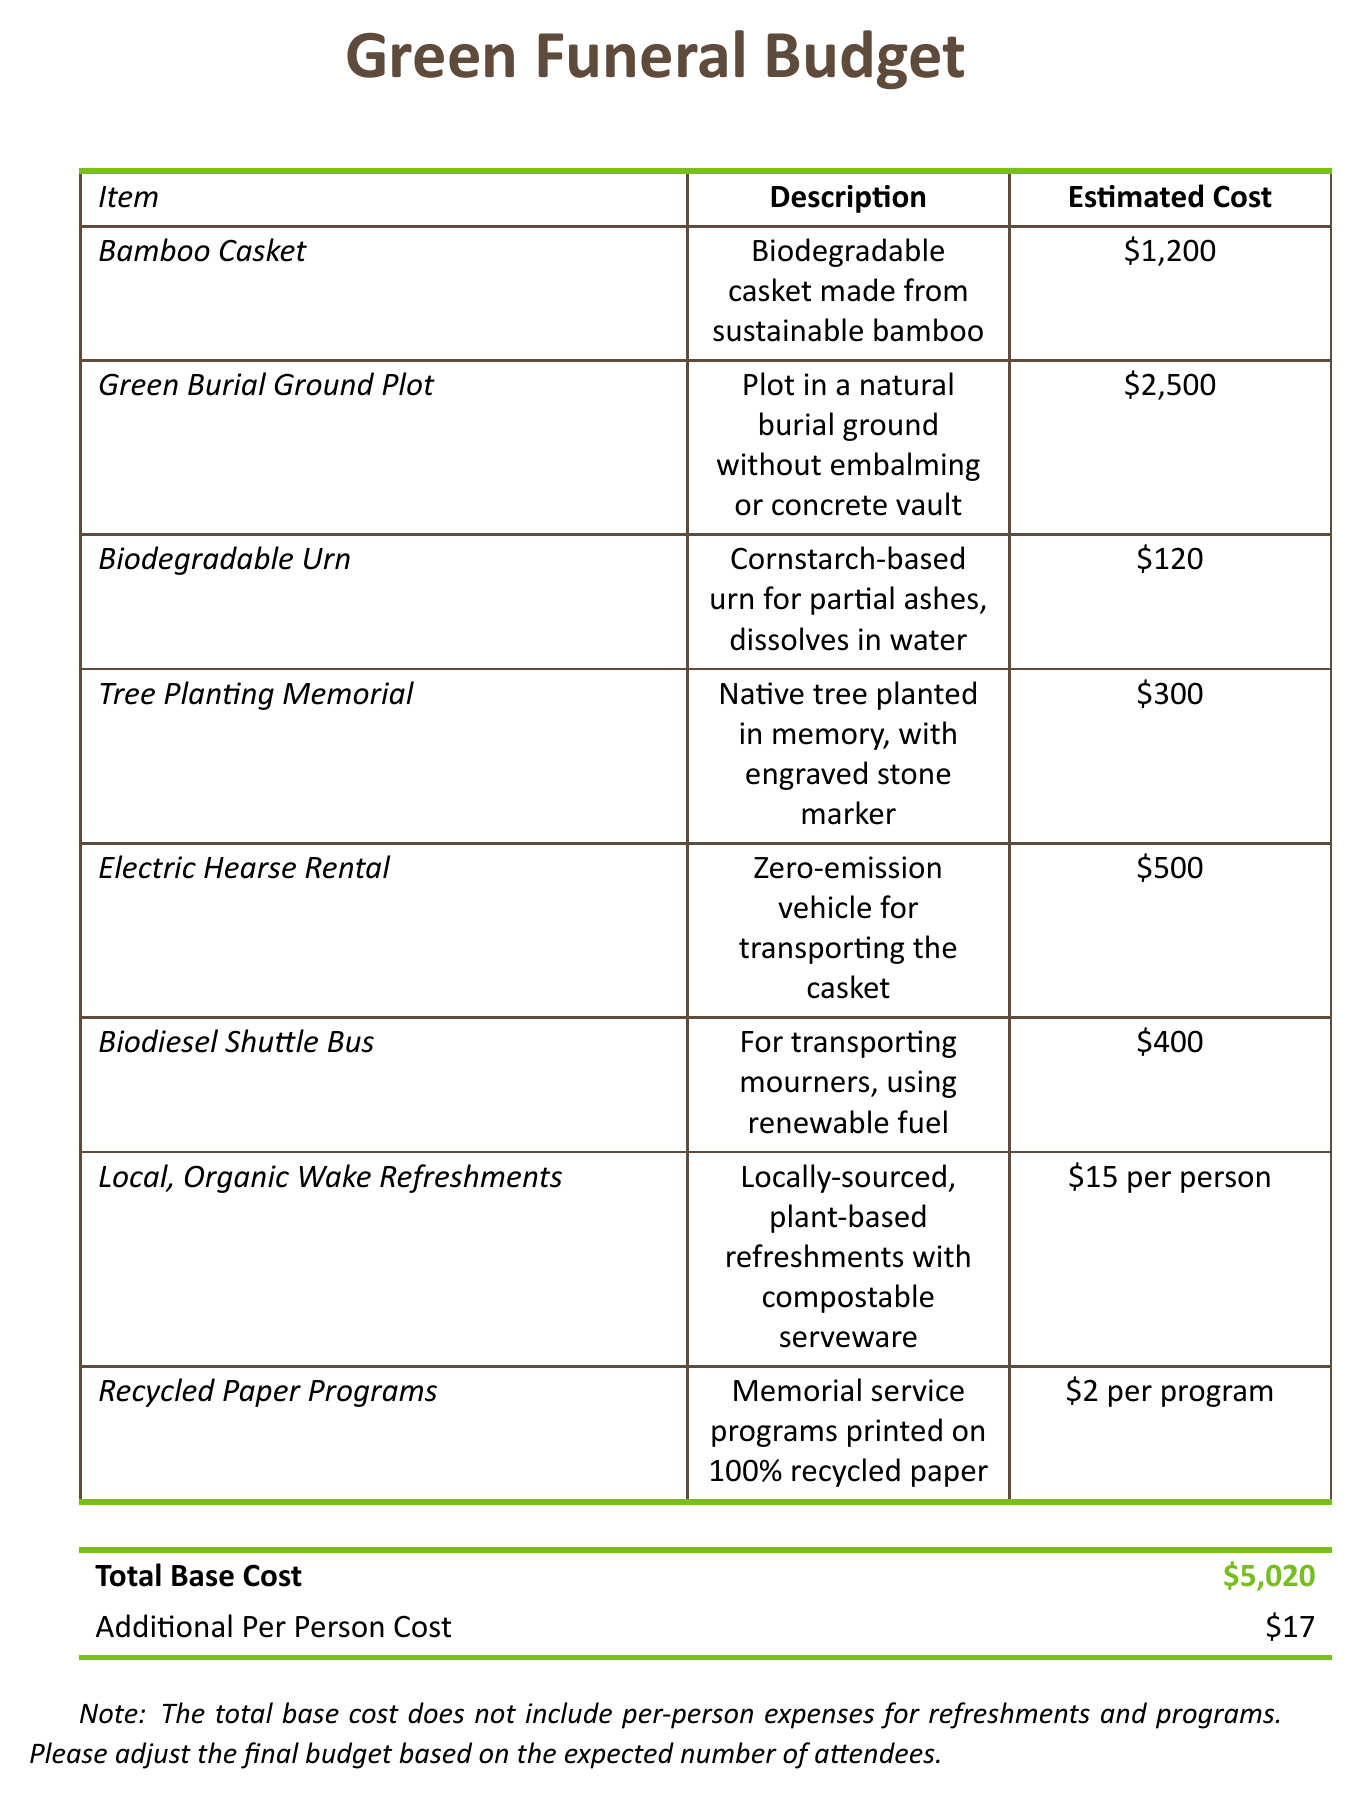What is the total base cost? The total base cost is summarized at the bottom of the document and is calculated from the itemized expenses.
Answer: $5,020 How much does a biodegradable urn cost? The document provides a specific cost for the biodegradable urn in the itemized list.
Answer: $120 What type of transportation is offered for mourners? The document lists transportation options, including a biodiesel shuttle bus which uses renewable fuel.
Answer: Biodiesel Shuttle Bus What is the cost per person for local, organic wake refreshments? The document specifies the estimated cost for refreshments per attendee.
Answer: $15 How much does the electric hearse rental cost? The cost for renting an electric hearse is detailed in the budget section of the document.
Answer: $500 What items are included in the green funeral? The document lists various items such as bamboo casket, tree planting memorial, and recycled paper programs.
Answer: Bamboo Casket, Tree Planting Memorial, Recycled Paper Programs What is the estimated cost to plant a tree memorial? The cost for a tree planting memorial is provided in the itemized list.
Answer: $300 How much does the recycled paper program cost per program? The document provides the specific cost for programs printed on recycled paper.
Answer: $2 per program What is the total additional cost per person? The document includes additional costs that should be calculated based on the number of participants.
Answer: $17 